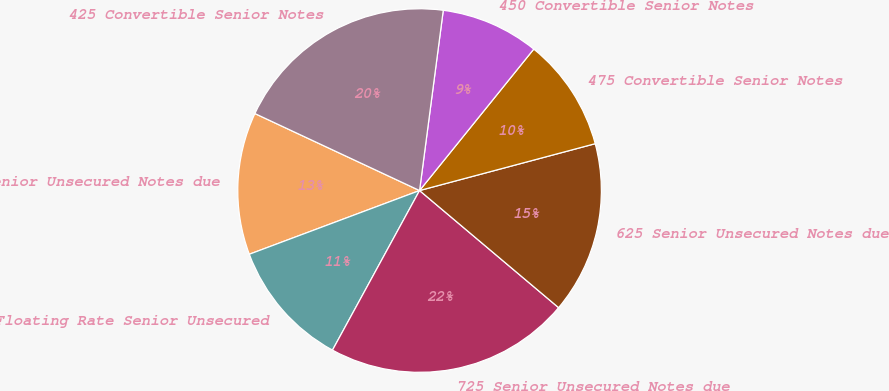Convert chart to OTSL. <chart><loc_0><loc_0><loc_500><loc_500><pie_chart><fcel>540 Senior Unsecured Notes due<fcel>Floating Rate Senior Unsecured<fcel>725 Senior Unsecured Notes due<fcel>625 Senior Unsecured Notes due<fcel>475 Convertible Senior Notes<fcel>450 Convertible Senior Notes<fcel>425 Convertible Senior Notes<nl><fcel>12.66%<fcel>11.35%<fcel>21.81%<fcel>15.29%<fcel>10.04%<fcel>8.73%<fcel>20.12%<nl></chart> 